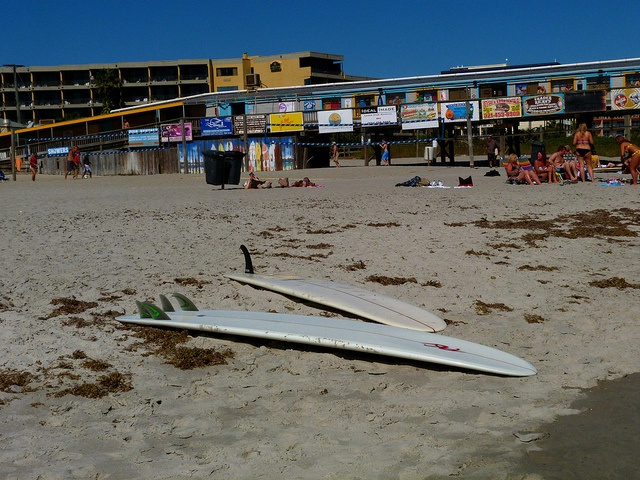Describe the objects in this image and their specific colors. I can see surfboard in darkblue, darkgray, black, lightgray, and gray tones, surfboard in darkblue, darkgray, gray, black, and lightgray tones, people in darkblue, black, gray, and maroon tones, people in darkblue, maroon, black, and brown tones, and people in darkblue, maroon, black, and brown tones in this image. 